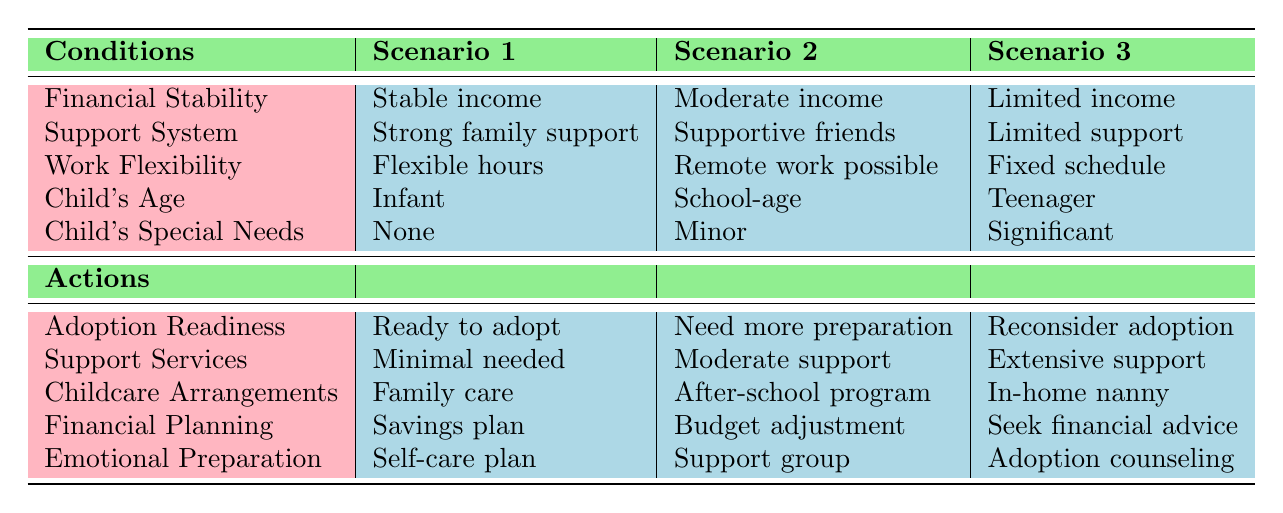What is the financial stability of Scenario 1? The table states that the financial stability in Scenario 1 is "Stable income."
Answer: Stable income Which scenario has the least support from family and friends? Scenario 3 lists "Limited support" under Support System, which indicates the least support available.
Answer: Scenario 3 What type of childcare arrangement is suggested for a teenager with significant special needs? In Scenario 3, the recommended childcare arrangement is "In-home nanny."
Answer: In-home nanny Is emotional preparation recommended for all scenarios? The table shows different emotional preparations for each scenario. Therefore, emotional preparation is not the same for all.
Answer: No In which scenario is the adoption readiness classified as "Ready to adopt"? The adoption readiness is classified as "Ready to adopt" in Scenario 1, according to the table.
Answer: Scenario 1 If a person has a moderate income and needs more support, what type of emotional preparation is suggested in Scenario 2? The emotional preparation suggested for Scenario 2 is a "Support group," as listed in the table.
Answer: Support group What is the average support service level between all three scenarios? The levels are: Minimal needed (1), Moderate support (2), Extensive support (3). The sum is 1 + 2 + 3 = 6, and the average is 6/3 = 2, which represents a moderate level.
Answer: Moderate support What is the implication of having fixed work schedule in the context of child adoption? The implication is indicated in Scenario 3, where significant support is required in the case of limited financial means and a teenager with special needs.
Answer: Extensive support needed If a single parent has a stable income and flexible work hours, what type of adoption readiness follows? Given the conditions in Scenario 1, the adoption readiness would be "Ready to adopt" as per the data in the table.
Answer: Ready to adopt 